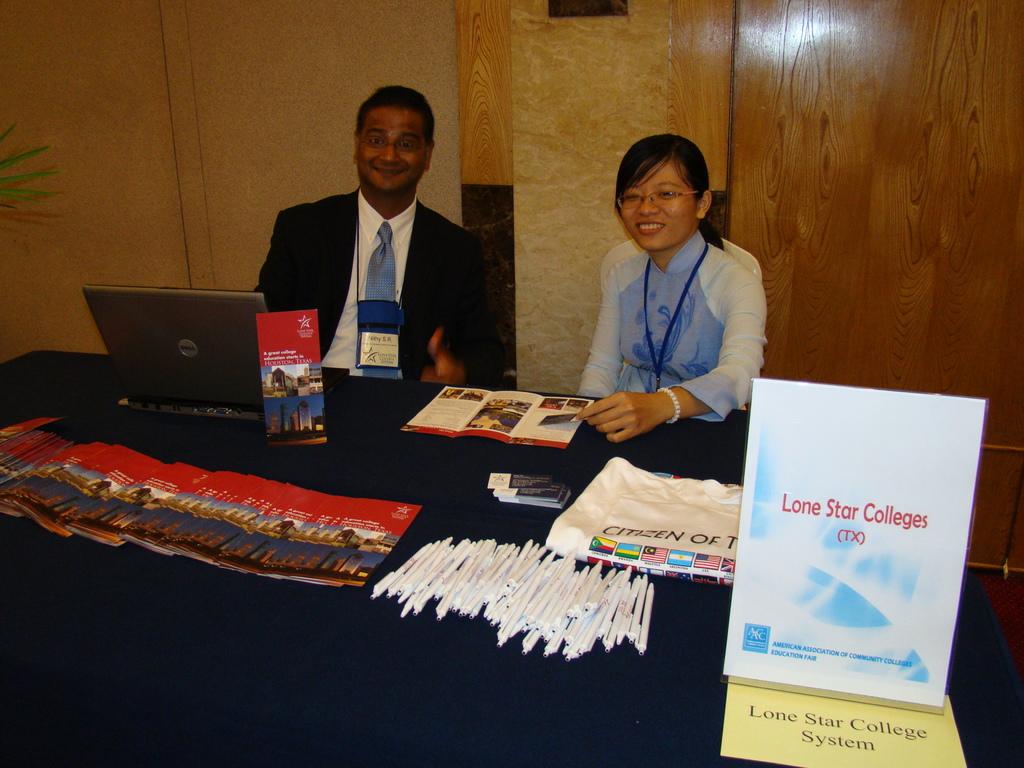What colleges are they representing?
Ensure brevity in your answer.  Lone star. 